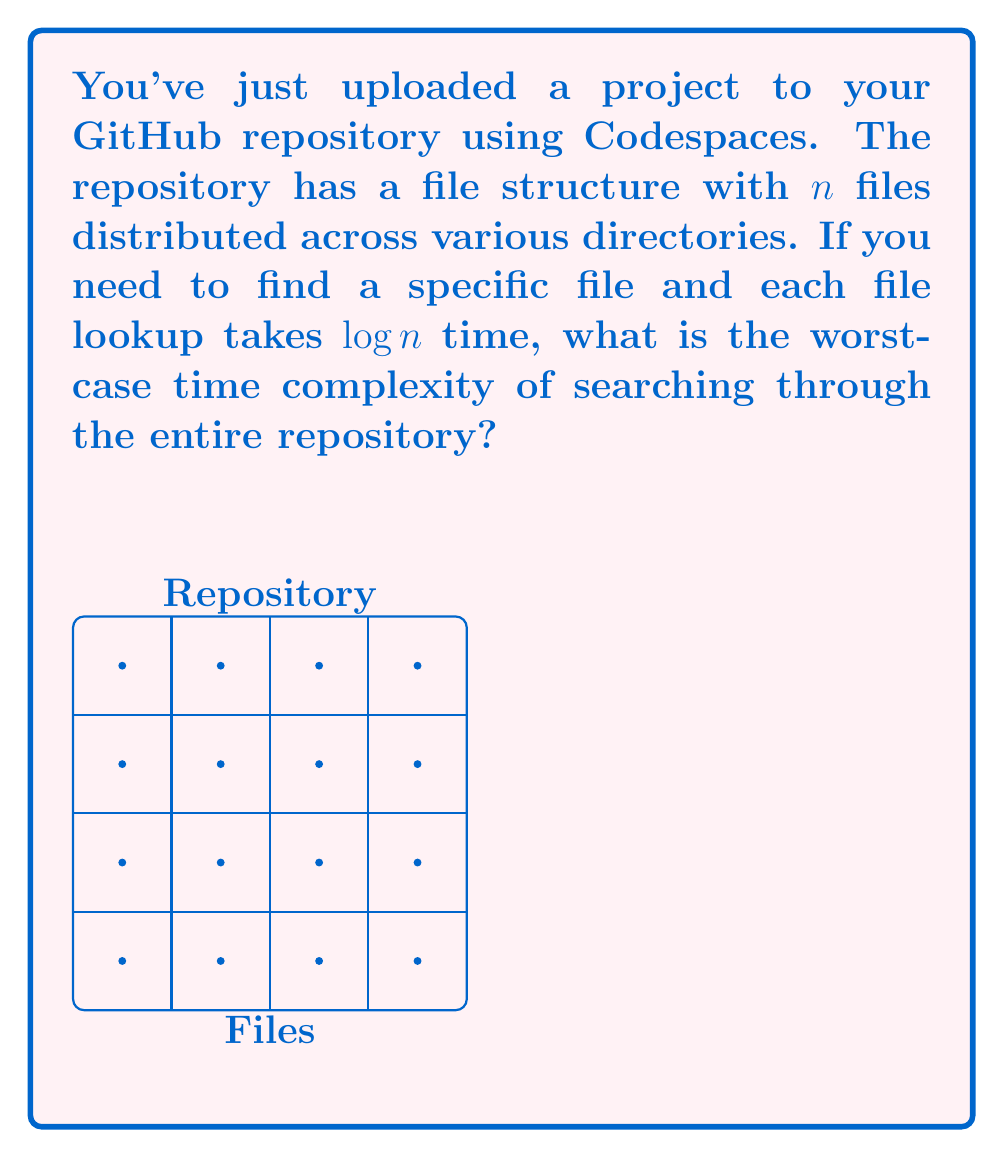Solve this math problem. Let's approach this step-by-step:

1) We have $n$ files in the repository.

2) For each file lookup, the time complexity is $\log n$. This suggests that the repository likely uses some form of efficient indexing or search tree structure.

3) In the worst-case scenario, we might need to look up every single file in the repository before finding the one we're searching for.

4) This means we would perform $n$ lookups, each taking $\log n$ time.

5) The total time complexity would be the number of lookups multiplied by the time for each lookup:

   $$ n \cdot \log n $$

6) In Big O notation, this is expressed as:

   $$ O(n \log n) $$

This is the worst-case time complexity for searching through the entire repository.
Answer: $O(n \log n)$ 